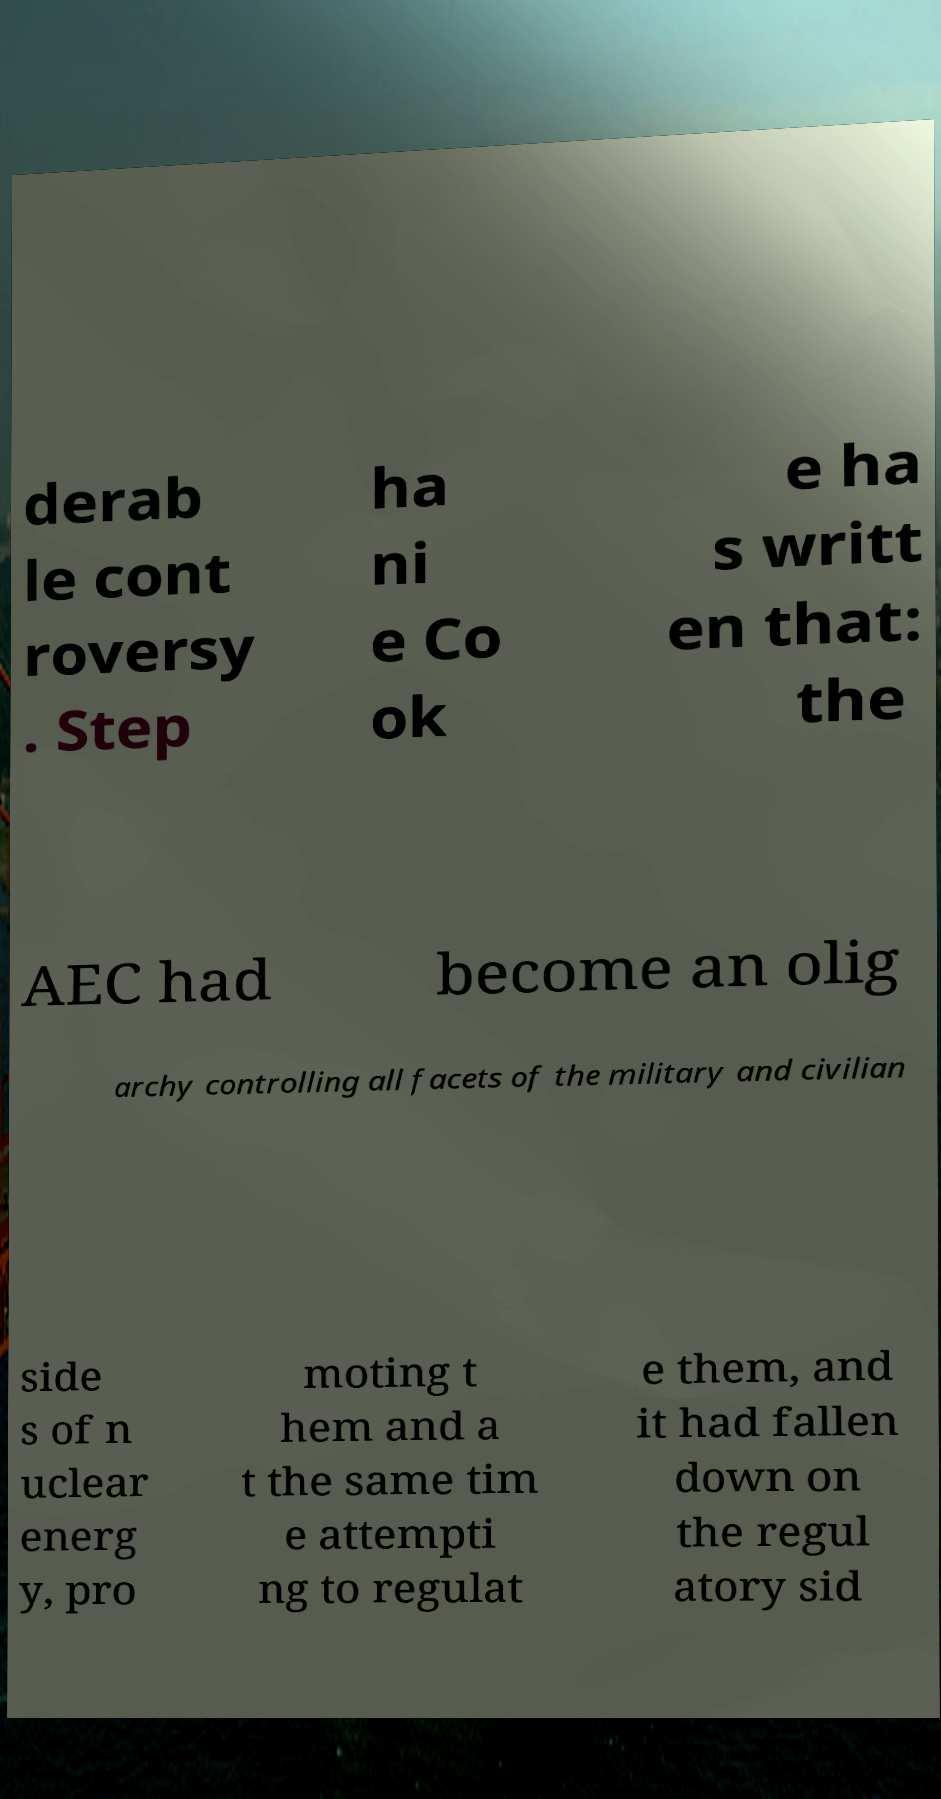Can you read and provide the text displayed in the image?This photo seems to have some interesting text. Can you extract and type it out for me? derab le cont roversy . Step ha ni e Co ok e ha s writt en that: the AEC had become an olig archy controlling all facets of the military and civilian side s of n uclear energ y, pro moting t hem and a t the same tim e attempti ng to regulat e them, and it had fallen down on the regul atory sid 